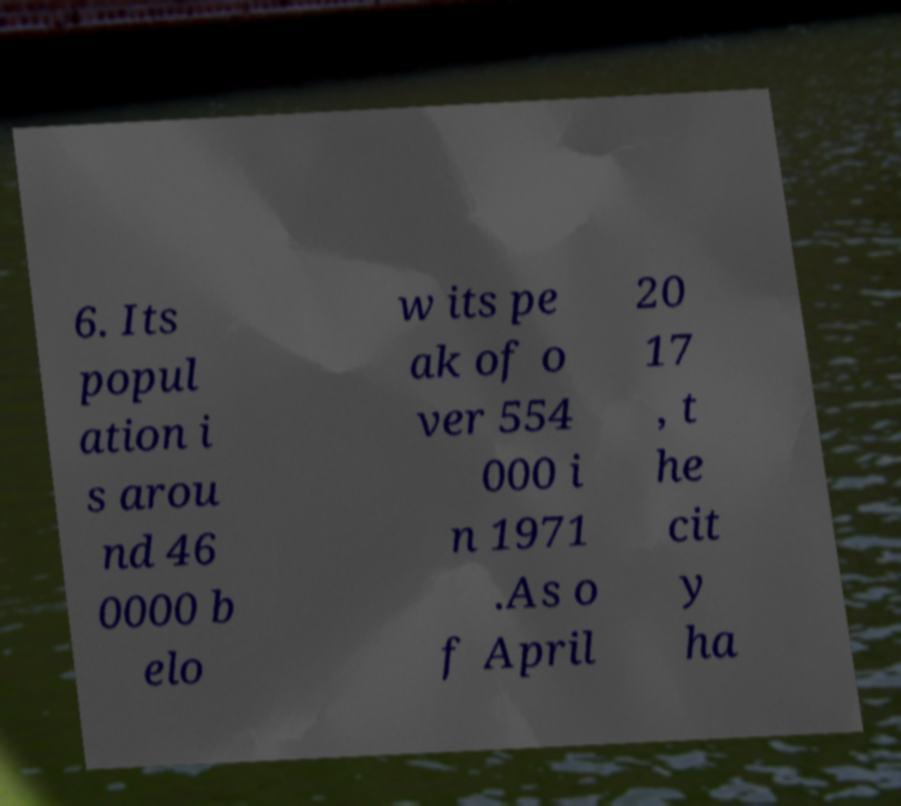Please identify and transcribe the text found in this image. 6. Its popul ation i s arou nd 46 0000 b elo w its pe ak of o ver 554 000 i n 1971 .As o f April 20 17 , t he cit y ha 